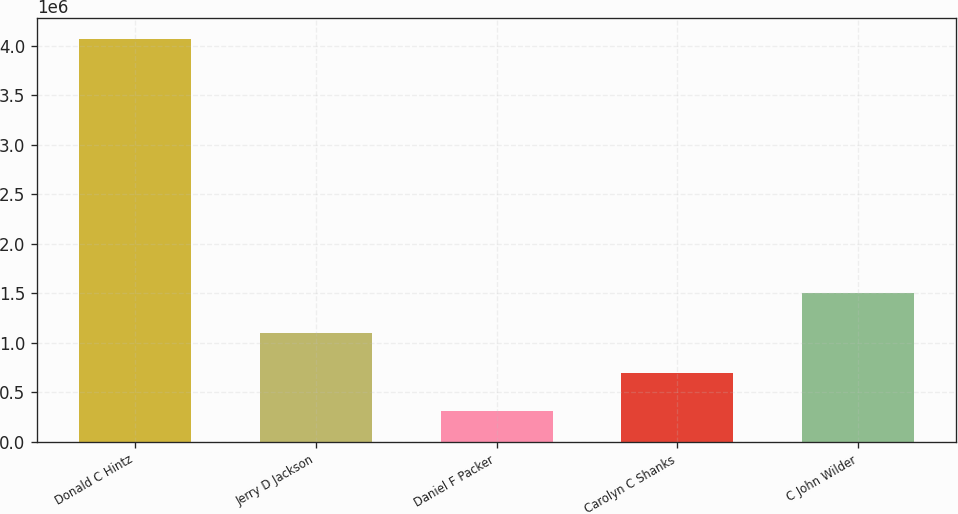<chart> <loc_0><loc_0><loc_500><loc_500><bar_chart><fcel>Donald C Hintz<fcel>Jerry D Jackson<fcel>Daniel F Packer<fcel>Carolyn C Shanks<fcel>C John Wilder<nl><fcel>4.07024e+06<fcel>1.09364e+06<fcel>313365<fcel>689052<fcel>1.50466e+06<nl></chart> 